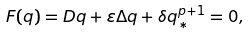Convert formula to latex. <formula><loc_0><loc_0><loc_500><loc_500>F ( q ) = D q + \varepsilon \Delta q + \delta q _ { * } ^ { p + 1 } = 0 ,</formula> 